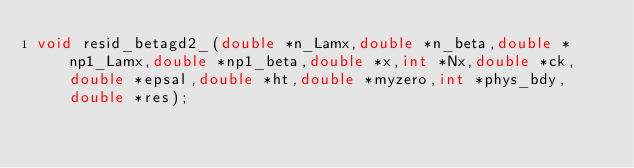Convert code to text. <code><loc_0><loc_0><loc_500><loc_500><_C_>void resid_betagd2_(double *n_Lamx,double *n_beta,double *np1_Lamx,double *np1_beta,double *x,int *Nx,double *ck,double *epsal,double *ht,double *myzero,int *phys_bdy,double *res);
</code> 